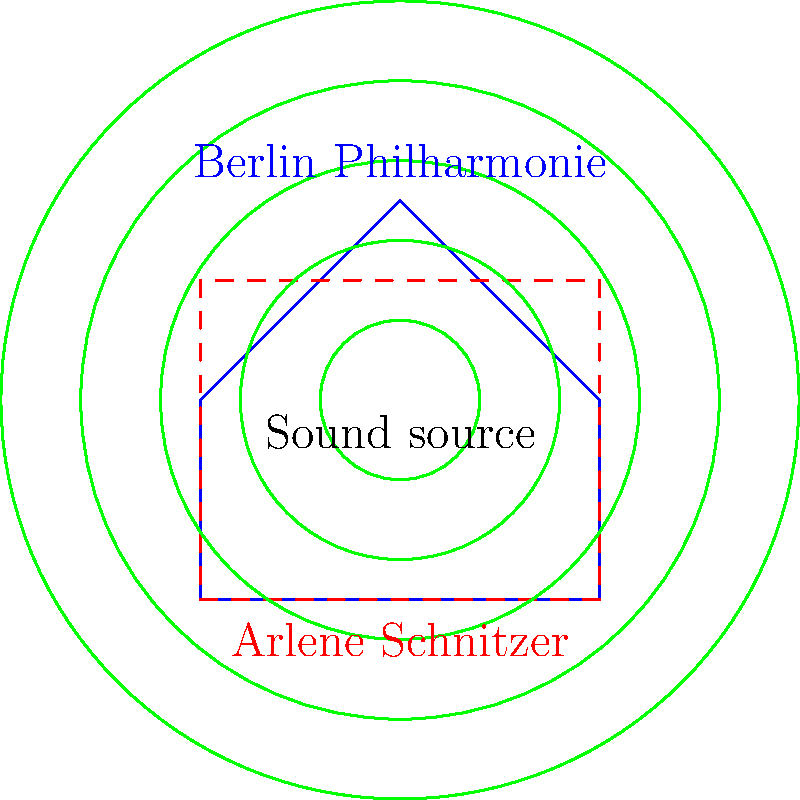Compare the wavefront patterns in Berlin's Philharmonie concert hall and Portland's Arlene Schnitzer Concert Hall, as shown in the diagram. How might the unique shape of the Philharmonie affect sound propagation compared to the more traditional rectangular shape of the Arlene Schnitzer Hall? Consider factors such as sound reflection and diffusion. To answer this question, let's analyze the diagram step-by-step:

1. Shape comparison:
   - Berlin Philharmonie: Pentagonal, asymmetrical shape
   - Arlene Schnitzer Hall: Rectangular shape

2. Wavefront propagation:
   - The green concentric circles represent sound wavefronts emanating from a central source.

3. Sound reflection:
   - In the Arlene Schnitzer Hall (rectangular):
     a. Parallel walls can create standing waves and flutter echoes.
     b. Sound reflections are more predictable and uniform.

   - In the Berlin Philharmonie (pentagonal):
     a. Non-parallel walls reduce standing waves and flutter echoes.
     b. Irregular reflections create a more diffuse sound field.

4. Sound diffusion:
   - Arlene Schnitzer Hall: Less natural diffusion due to regular shape.
   - Berlin Philharmonie: Greater natural diffusion due to irregular shape.

5. Acoustic implications:
   - Berlin Philharmonie:
     a. More even sound distribution throughout the hall.
     b. Enhanced sense of envelopment for the audience.
     c. Reduced need for additional acoustic treatments.

   - Arlene Schnitzer Hall:
     a. Potential for more focused sound in certain areas.
     b. May require additional acoustic treatments to achieve desired diffusion.

6. Listener experience:
   - Berlin Philharmonie: More immersive, with sound coming from multiple directions.
   - Arlene Schnitzer Hall: More traditional front-to-back sound propagation.

The unique shape of the Berlin Philharmonie is likely to result in a more diffuse and enveloping sound field, potentially offering a more immersive acoustic experience compared to the more traditional rectangular shape of the Arlene Schnitzer Hall.
Answer: The Philharmonie's pentagonal shape promotes more diffuse sound reflections and even distribution, while the Arlene Schnitzer Hall's rectangular shape may lead to more predictable but potentially less immersive acoustics. 